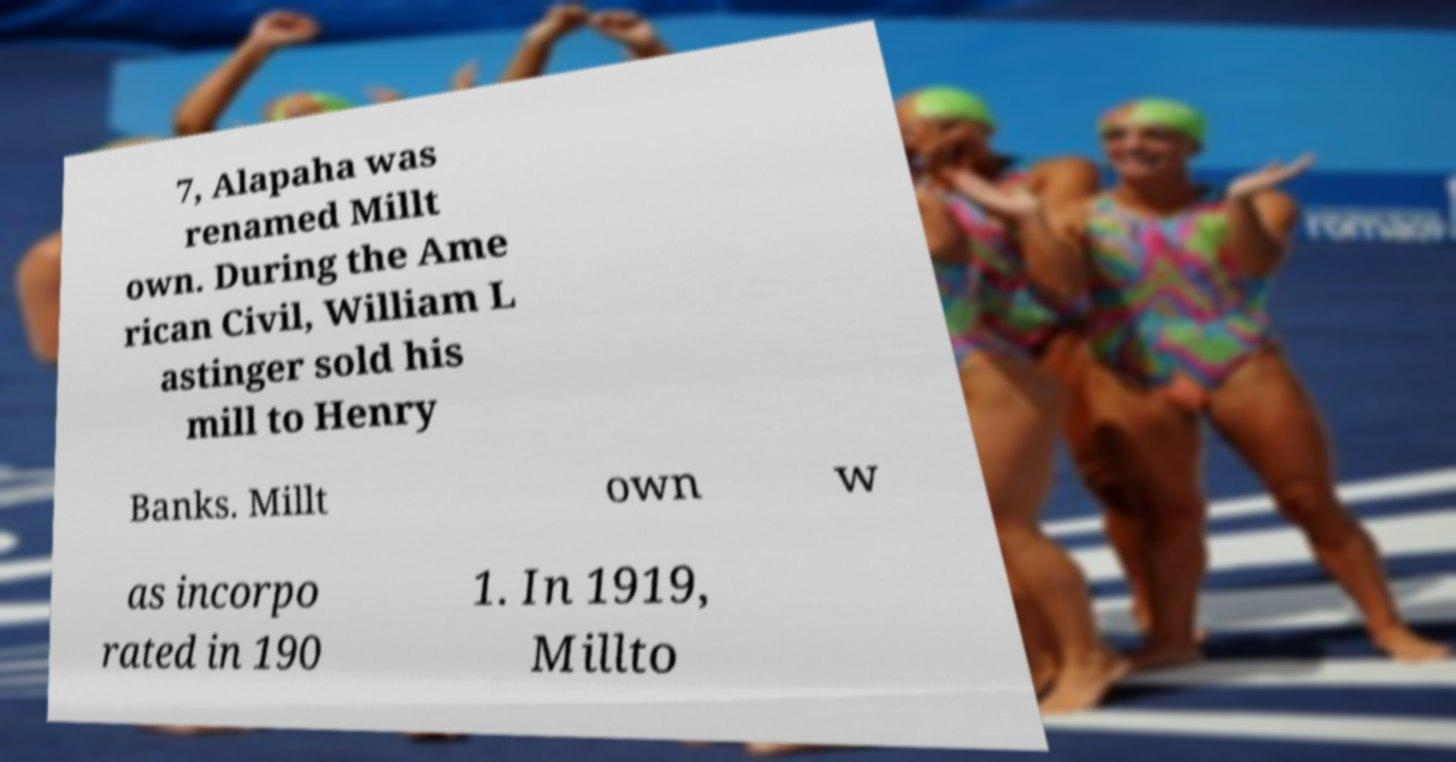Could you extract and type out the text from this image? 7, Alapaha was renamed Millt own. During the Ame rican Civil, William L astinger sold his mill to Henry Banks. Millt own w as incorpo rated in 190 1. In 1919, Millto 